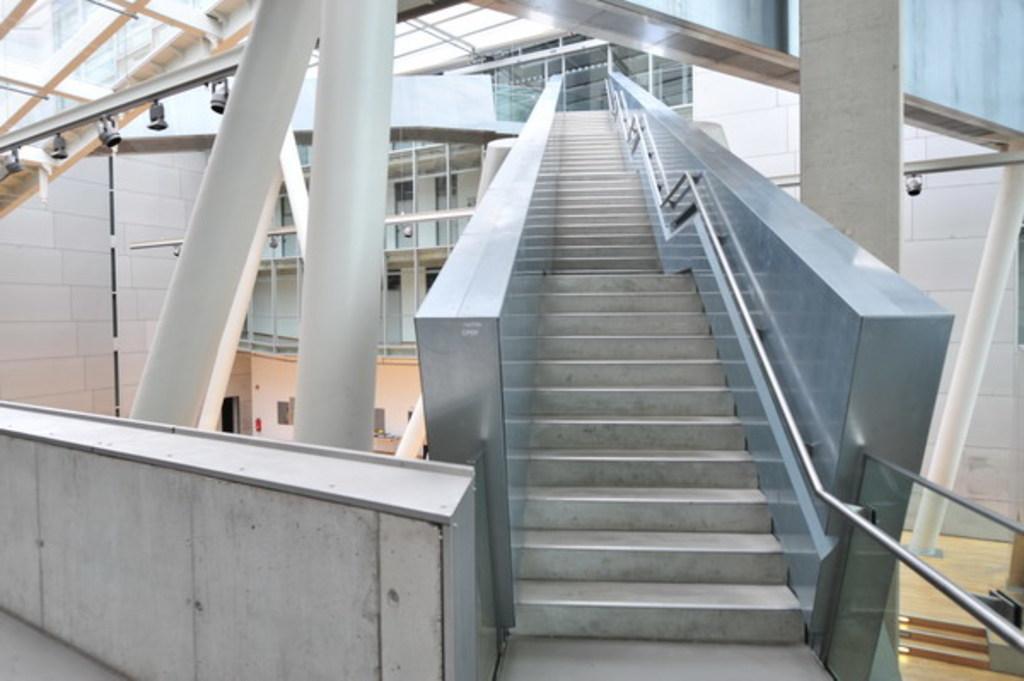In one or two sentences, can you explain what this image depicts? In this picture we can see a wall and staircase, beside this staircase we can see pillars, rods, pipes, lights and some objects, on the right side we can see a floor. 